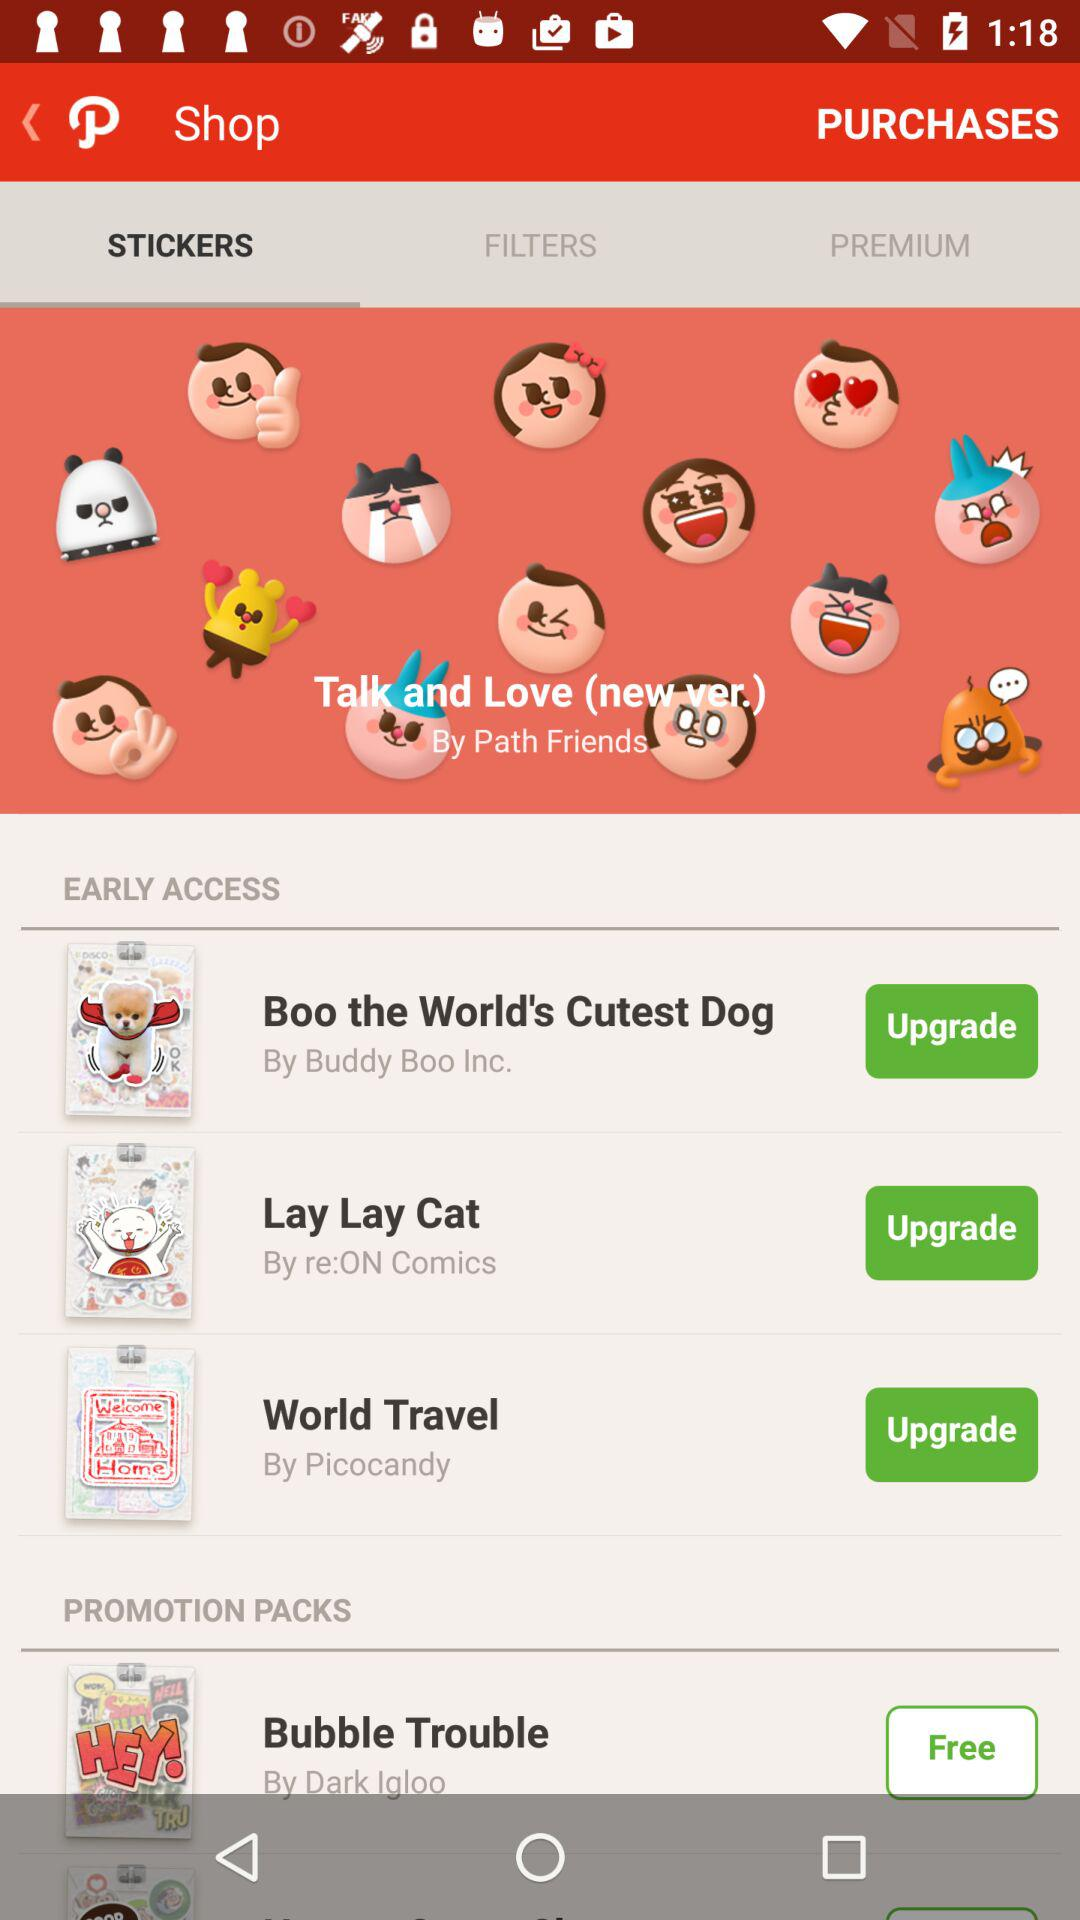What's the name of the promotion pack by Dark Igloo? The name of the promotion pack is "Bubble Trouble". 